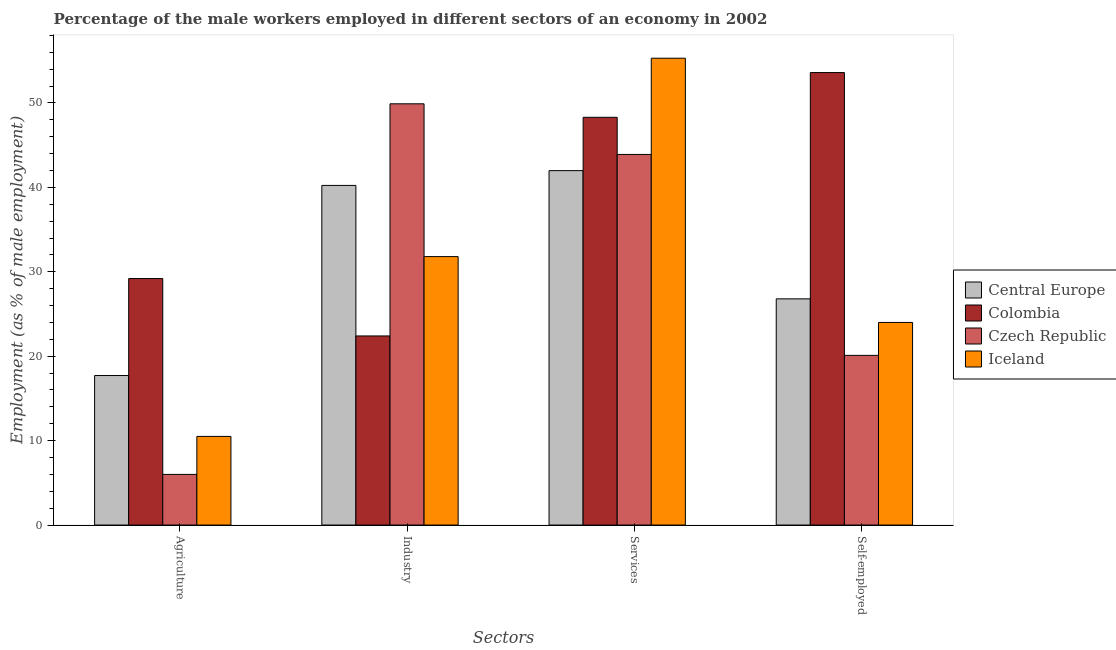How many different coloured bars are there?
Provide a succinct answer. 4. Are the number of bars per tick equal to the number of legend labels?
Provide a short and direct response. Yes. How many bars are there on the 2nd tick from the left?
Offer a terse response. 4. How many bars are there on the 2nd tick from the right?
Keep it short and to the point. 4. What is the label of the 2nd group of bars from the left?
Keep it short and to the point. Industry. What is the percentage of male workers in industry in Central Europe?
Give a very brief answer. 40.23. Across all countries, what is the maximum percentage of self employed male workers?
Offer a terse response. 53.6. Across all countries, what is the minimum percentage of male workers in agriculture?
Give a very brief answer. 6. In which country was the percentage of male workers in agriculture maximum?
Ensure brevity in your answer.  Colombia. In which country was the percentage of male workers in services minimum?
Offer a very short reply. Central Europe. What is the total percentage of male workers in services in the graph?
Provide a short and direct response. 189.48. What is the difference between the percentage of male workers in services in Iceland and that in Central Europe?
Keep it short and to the point. 13.32. What is the difference between the percentage of self employed male workers in Iceland and the percentage of male workers in industry in Central Europe?
Your response must be concise. -16.23. What is the average percentage of male workers in agriculture per country?
Keep it short and to the point. 15.85. What is the difference between the percentage of male workers in agriculture and percentage of male workers in industry in Iceland?
Your answer should be very brief. -21.3. What is the ratio of the percentage of self employed male workers in Iceland to that in Central Europe?
Make the answer very short. 0.9. Is the percentage of male workers in industry in Iceland less than that in Czech Republic?
Your answer should be compact. Yes. What is the difference between the highest and the second highest percentage of self employed male workers?
Offer a very short reply. 26.8. What is the difference between the highest and the lowest percentage of male workers in agriculture?
Offer a very short reply. 23.2. In how many countries, is the percentage of male workers in industry greater than the average percentage of male workers in industry taken over all countries?
Ensure brevity in your answer.  2. Is the sum of the percentage of self employed male workers in Iceland and Czech Republic greater than the maximum percentage of male workers in industry across all countries?
Give a very brief answer. No. Is it the case that in every country, the sum of the percentage of self employed male workers and percentage of male workers in services is greater than the sum of percentage of male workers in industry and percentage of male workers in agriculture?
Give a very brief answer. Yes. What does the 1st bar from the left in Industry represents?
Give a very brief answer. Central Europe. What does the 4th bar from the right in Industry represents?
Offer a terse response. Central Europe. How many countries are there in the graph?
Ensure brevity in your answer.  4. Are the values on the major ticks of Y-axis written in scientific E-notation?
Make the answer very short. No. Does the graph contain any zero values?
Your response must be concise. No. Where does the legend appear in the graph?
Your answer should be compact. Center right. How many legend labels are there?
Provide a short and direct response. 4. How are the legend labels stacked?
Your answer should be compact. Vertical. What is the title of the graph?
Ensure brevity in your answer.  Percentage of the male workers employed in different sectors of an economy in 2002. Does "Brunei Darussalam" appear as one of the legend labels in the graph?
Provide a short and direct response. No. What is the label or title of the X-axis?
Your answer should be very brief. Sectors. What is the label or title of the Y-axis?
Make the answer very short. Employment (as % of male employment). What is the Employment (as % of male employment) in Central Europe in Agriculture?
Offer a very short reply. 17.71. What is the Employment (as % of male employment) of Colombia in Agriculture?
Make the answer very short. 29.2. What is the Employment (as % of male employment) of Central Europe in Industry?
Provide a succinct answer. 40.23. What is the Employment (as % of male employment) in Colombia in Industry?
Provide a succinct answer. 22.4. What is the Employment (as % of male employment) in Czech Republic in Industry?
Make the answer very short. 49.9. What is the Employment (as % of male employment) in Iceland in Industry?
Offer a terse response. 31.8. What is the Employment (as % of male employment) in Central Europe in Services?
Ensure brevity in your answer.  41.98. What is the Employment (as % of male employment) in Colombia in Services?
Offer a terse response. 48.3. What is the Employment (as % of male employment) in Czech Republic in Services?
Give a very brief answer. 43.9. What is the Employment (as % of male employment) of Iceland in Services?
Ensure brevity in your answer.  55.3. What is the Employment (as % of male employment) in Central Europe in Self-employed?
Make the answer very short. 26.8. What is the Employment (as % of male employment) in Colombia in Self-employed?
Keep it short and to the point. 53.6. What is the Employment (as % of male employment) of Czech Republic in Self-employed?
Your answer should be very brief. 20.1. Across all Sectors, what is the maximum Employment (as % of male employment) of Central Europe?
Provide a succinct answer. 41.98. Across all Sectors, what is the maximum Employment (as % of male employment) in Colombia?
Give a very brief answer. 53.6. Across all Sectors, what is the maximum Employment (as % of male employment) of Czech Republic?
Give a very brief answer. 49.9. Across all Sectors, what is the maximum Employment (as % of male employment) in Iceland?
Provide a succinct answer. 55.3. Across all Sectors, what is the minimum Employment (as % of male employment) of Central Europe?
Provide a succinct answer. 17.71. Across all Sectors, what is the minimum Employment (as % of male employment) in Colombia?
Ensure brevity in your answer.  22.4. What is the total Employment (as % of male employment) of Central Europe in the graph?
Your response must be concise. 126.72. What is the total Employment (as % of male employment) in Colombia in the graph?
Your answer should be very brief. 153.5. What is the total Employment (as % of male employment) of Czech Republic in the graph?
Your response must be concise. 119.9. What is the total Employment (as % of male employment) in Iceland in the graph?
Provide a short and direct response. 121.6. What is the difference between the Employment (as % of male employment) of Central Europe in Agriculture and that in Industry?
Make the answer very short. -22.52. What is the difference between the Employment (as % of male employment) of Czech Republic in Agriculture and that in Industry?
Your response must be concise. -43.9. What is the difference between the Employment (as % of male employment) in Iceland in Agriculture and that in Industry?
Provide a succinct answer. -21.3. What is the difference between the Employment (as % of male employment) in Central Europe in Agriculture and that in Services?
Give a very brief answer. -24.27. What is the difference between the Employment (as % of male employment) of Colombia in Agriculture and that in Services?
Your answer should be compact. -19.1. What is the difference between the Employment (as % of male employment) of Czech Republic in Agriculture and that in Services?
Keep it short and to the point. -37.9. What is the difference between the Employment (as % of male employment) in Iceland in Agriculture and that in Services?
Ensure brevity in your answer.  -44.8. What is the difference between the Employment (as % of male employment) in Central Europe in Agriculture and that in Self-employed?
Your response must be concise. -9.08. What is the difference between the Employment (as % of male employment) of Colombia in Agriculture and that in Self-employed?
Your answer should be very brief. -24.4. What is the difference between the Employment (as % of male employment) in Czech Republic in Agriculture and that in Self-employed?
Ensure brevity in your answer.  -14.1. What is the difference between the Employment (as % of male employment) of Central Europe in Industry and that in Services?
Ensure brevity in your answer.  -1.75. What is the difference between the Employment (as % of male employment) in Colombia in Industry and that in Services?
Provide a short and direct response. -25.9. What is the difference between the Employment (as % of male employment) of Czech Republic in Industry and that in Services?
Provide a short and direct response. 6. What is the difference between the Employment (as % of male employment) of Iceland in Industry and that in Services?
Provide a short and direct response. -23.5. What is the difference between the Employment (as % of male employment) in Central Europe in Industry and that in Self-employed?
Offer a terse response. 13.44. What is the difference between the Employment (as % of male employment) in Colombia in Industry and that in Self-employed?
Provide a succinct answer. -31.2. What is the difference between the Employment (as % of male employment) of Czech Republic in Industry and that in Self-employed?
Offer a very short reply. 29.8. What is the difference between the Employment (as % of male employment) of Central Europe in Services and that in Self-employed?
Keep it short and to the point. 15.19. What is the difference between the Employment (as % of male employment) in Colombia in Services and that in Self-employed?
Your answer should be compact. -5.3. What is the difference between the Employment (as % of male employment) of Czech Republic in Services and that in Self-employed?
Provide a succinct answer. 23.8. What is the difference between the Employment (as % of male employment) in Iceland in Services and that in Self-employed?
Provide a succinct answer. 31.3. What is the difference between the Employment (as % of male employment) in Central Europe in Agriculture and the Employment (as % of male employment) in Colombia in Industry?
Offer a very short reply. -4.69. What is the difference between the Employment (as % of male employment) in Central Europe in Agriculture and the Employment (as % of male employment) in Czech Republic in Industry?
Make the answer very short. -32.19. What is the difference between the Employment (as % of male employment) in Central Europe in Agriculture and the Employment (as % of male employment) in Iceland in Industry?
Provide a succinct answer. -14.09. What is the difference between the Employment (as % of male employment) in Colombia in Agriculture and the Employment (as % of male employment) in Czech Republic in Industry?
Give a very brief answer. -20.7. What is the difference between the Employment (as % of male employment) of Czech Republic in Agriculture and the Employment (as % of male employment) of Iceland in Industry?
Provide a short and direct response. -25.8. What is the difference between the Employment (as % of male employment) of Central Europe in Agriculture and the Employment (as % of male employment) of Colombia in Services?
Offer a very short reply. -30.59. What is the difference between the Employment (as % of male employment) in Central Europe in Agriculture and the Employment (as % of male employment) in Czech Republic in Services?
Provide a succinct answer. -26.19. What is the difference between the Employment (as % of male employment) of Central Europe in Agriculture and the Employment (as % of male employment) of Iceland in Services?
Give a very brief answer. -37.59. What is the difference between the Employment (as % of male employment) in Colombia in Agriculture and the Employment (as % of male employment) in Czech Republic in Services?
Make the answer very short. -14.7. What is the difference between the Employment (as % of male employment) of Colombia in Agriculture and the Employment (as % of male employment) of Iceland in Services?
Offer a very short reply. -26.1. What is the difference between the Employment (as % of male employment) of Czech Republic in Agriculture and the Employment (as % of male employment) of Iceland in Services?
Keep it short and to the point. -49.3. What is the difference between the Employment (as % of male employment) in Central Europe in Agriculture and the Employment (as % of male employment) in Colombia in Self-employed?
Give a very brief answer. -35.89. What is the difference between the Employment (as % of male employment) of Central Europe in Agriculture and the Employment (as % of male employment) of Czech Republic in Self-employed?
Your answer should be compact. -2.39. What is the difference between the Employment (as % of male employment) of Central Europe in Agriculture and the Employment (as % of male employment) of Iceland in Self-employed?
Offer a terse response. -6.29. What is the difference between the Employment (as % of male employment) in Colombia in Agriculture and the Employment (as % of male employment) in Czech Republic in Self-employed?
Keep it short and to the point. 9.1. What is the difference between the Employment (as % of male employment) of Colombia in Agriculture and the Employment (as % of male employment) of Iceland in Self-employed?
Your answer should be very brief. 5.2. What is the difference between the Employment (as % of male employment) in Czech Republic in Agriculture and the Employment (as % of male employment) in Iceland in Self-employed?
Offer a very short reply. -18. What is the difference between the Employment (as % of male employment) of Central Europe in Industry and the Employment (as % of male employment) of Colombia in Services?
Provide a short and direct response. -8.07. What is the difference between the Employment (as % of male employment) of Central Europe in Industry and the Employment (as % of male employment) of Czech Republic in Services?
Your response must be concise. -3.67. What is the difference between the Employment (as % of male employment) of Central Europe in Industry and the Employment (as % of male employment) of Iceland in Services?
Offer a terse response. -15.07. What is the difference between the Employment (as % of male employment) of Colombia in Industry and the Employment (as % of male employment) of Czech Republic in Services?
Make the answer very short. -21.5. What is the difference between the Employment (as % of male employment) in Colombia in Industry and the Employment (as % of male employment) in Iceland in Services?
Your response must be concise. -32.9. What is the difference between the Employment (as % of male employment) in Central Europe in Industry and the Employment (as % of male employment) in Colombia in Self-employed?
Offer a very short reply. -13.37. What is the difference between the Employment (as % of male employment) of Central Europe in Industry and the Employment (as % of male employment) of Czech Republic in Self-employed?
Provide a short and direct response. 20.13. What is the difference between the Employment (as % of male employment) in Central Europe in Industry and the Employment (as % of male employment) in Iceland in Self-employed?
Offer a very short reply. 16.23. What is the difference between the Employment (as % of male employment) in Colombia in Industry and the Employment (as % of male employment) in Czech Republic in Self-employed?
Make the answer very short. 2.3. What is the difference between the Employment (as % of male employment) in Czech Republic in Industry and the Employment (as % of male employment) in Iceland in Self-employed?
Give a very brief answer. 25.9. What is the difference between the Employment (as % of male employment) in Central Europe in Services and the Employment (as % of male employment) in Colombia in Self-employed?
Your answer should be very brief. -11.62. What is the difference between the Employment (as % of male employment) of Central Europe in Services and the Employment (as % of male employment) of Czech Republic in Self-employed?
Make the answer very short. 21.88. What is the difference between the Employment (as % of male employment) of Central Europe in Services and the Employment (as % of male employment) of Iceland in Self-employed?
Offer a very short reply. 17.98. What is the difference between the Employment (as % of male employment) in Colombia in Services and the Employment (as % of male employment) in Czech Republic in Self-employed?
Provide a succinct answer. 28.2. What is the difference between the Employment (as % of male employment) in Colombia in Services and the Employment (as % of male employment) in Iceland in Self-employed?
Give a very brief answer. 24.3. What is the average Employment (as % of male employment) in Central Europe per Sectors?
Your response must be concise. 31.68. What is the average Employment (as % of male employment) in Colombia per Sectors?
Offer a terse response. 38.38. What is the average Employment (as % of male employment) in Czech Republic per Sectors?
Provide a short and direct response. 29.98. What is the average Employment (as % of male employment) in Iceland per Sectors?
Keep it short and to the point. 30.4. What is the difference between the Employment (as % of male employment) of Central Europe and Employment (as % of male employment) of Colombia in Agriculture?
Your answer should be compact. -11.49. What is the difference between the Employment (as % of male employment) of Central Europe and Employment (as % of male employment) of Czech Republic in Agriculture?
Your answer should be compact. 11.71. What is the difference between the Employment (as % of male employment) of Central Europe and Employment (as % of male employment) of Iceland in Agriculture?
Provide a succinct answer. 7.21. What is the difference between the Employment (as % of male employment) of Colombia and Employment (as % of male employment) of Czech Republic in Agriculture?
Offer a terse response. 23.2. What is the difference between the Employment (as % of male employment) of Central Europe and Employment (as % of male employment) of Colombia in Industry?
Provide a succinct answer. 17.83. What is the difference between the Employment (as % of male employment) in Central Europe and Employment (as % of male employment) in Czech Republic in Industry?
Provide a succinct answer. -9.67. What is the difference between the Employment (as % of male employment) in Central Europe and Employment (as % of male employment) in Iceland in Industry?
Your answer should be compact. 8.43. What is the difference between the Employment (as % of male employment) in Colombia and Employment (as % of male employment) in Czech Republic in Industry?
Provide a succinct answer. -27.5. What is the difference between the Employment (as % of male employment) in Czech Republic and Employment (as % of male employment) in Iceland in Industry?
Your answer should be very brief. 18.1. What is the difference between the Employment (as % of male employment) in Central Europe and Employment (as % of male employment) in Colombia in Services?
Give a very brief answer. -6.32. What is the difference between the Employment (as % of male employment) of Central Europe and Employment (as % of male employment) of Czech Republic in Services?
Ensure brevity in your answer.  -1.92. What is the difference between the Employment (as % of male employment) of Central Europe and Employment (as % of male employment) of Iceland in Services?
Provide a short and direct response. -13.32. What is the difference between the Employment (as % of male employment) of Colombia and Employment (as % of male employment) of Iceland in Services?
Offer a very short reply. -7. What is the difference between the Employment (as % of male employment) in Czech Republic and Employment (as % of male employment) in Iceland in Services?
Give a very brief answer. -11.4. What is the difference between the Employment (as % of male employment) in Central Europe and Employment (as % of male employment) in Colombia in Self-employed?
Provide a short and direct response. -26.8. What is the difference between the Employment (as % of male employment) of Central Europe and Employment (as % of male employment) of Czech Republic in Self-employed?
Your answer should be compact. 6.7. What is the difference between the Employment (as % of male employment) in Central Europe and Employment (as % of male employment) in Iceland in Self-employed?
Ensure brevity in your answer.  2.8. What is the difference between the Employment (as % of male employment) in Colombia and Employment (as % of male employment) in Czech Republic in Self-employed?
Provide a short and direct response. 33.5. What is the difference between the Employment (as % of male employment) of Colombia and Employment (as % of male employment) of Iceland in Self-employed?
Provide a short and direct response. 29.6. What is the difference between the Employment (as % of male employment) in Czech Republic and Employment (as % of male employment) in Iceland in Self-employed?
Your response must be concise. -3.9. What is the ratio of the Employment (as % of male employment) in Central Europe in Agriculture to that in Industry?
Provide a short and direct response. 0.44. What is the ratio of the Employment (as % of male employment) of Colombia in Agriculture to that in Industry?
Your answer should be very brief. 1.3. What is the ratio of the Employment (as % of male employment) in Czech Republic in Agriculture to that in Industry?
Give a very brief answer. 0.12. What is the ratio of the Employment (as % of male employment) in Iceland in Agriculture to that in Industry?
Keep it short and to the point. 0.33. What is the ratio of the Employment (as % of male employment) in Central Europe in Agriculture to that in Services?
Your answer should be compact. 0.42. What is the ratio of the Employment (as % of male employment) in Colombia in Agriculture to that in Services?
Offer a very short reply. 0.6. What is the ratio of the Employment (as % of male employment) in Czech Republic in Agriculture to that in Services?
Provide a short and direct response. 0.14. What is the ratio of the Employment (as % of male employment) of Iceland in Agriculture to that in Services?
Ensure brevity in your answer.  0.19. What is the ratio of the Employment (as % of male employment) of Central Europe in Agriculture to that in Self-employed?
Keep it short and to the point. 0.66. What is the ratio of the Employment (as % of male employment) of Colombia in Agriculture to that in Self-employed?
Provide a short and direct response. 0.54. What is the ratio of the Employment (as % of male employment) in Czech Republic in Agriculture to that in Self-employed?
Give a very brief answer. 0.3. What is the ratio of the Employment (as % of male employment) in Iceland in Agriculture to that in Self-employed?
Offer a terse response. 0.44. What is the ratio of the Employment (as % of male employment) of Colombia in Industry to that in Services?
Offer a very short reply. 0.46. What is the ratio of the Employment (as % of male employment) in Czech Republic in Industry to that in Services?
Your answer should be very brief. 1.14. What is the ratio of the Employment (as % of male employment) in Iceland in Industry to that in Services?
Provide a succinct answer. 0.57. What is the ratio of the Employment (as % of male employment) in Central Europe in Industry to that in Self-employed?
Provide a short and direct response. 1.5. What is the ratio of the Employment (as % of male employment) in Colombia in Industry to that in Self-employed?
Your answer should be very brief. 0.42. What is the ratio of the Employment (as % of male employment) in Czech Republic in Industry to that in Self-employed?
Your answer should be compact. 2.48. What is the ratio of the Employment (as % of male employment) of Iceland in Industry to that in Self-employed?
Keep it short and to the point. 1.32. What is the ratio of the Employment (as % of male employment) in Central Europe in Services to that in Self-employed?
Keep it short and to the point. 1.57. What is the ratio of the Employment (as % of male employment) in Colombia in Services to that in Self-employed?
Your response must be concise. 0.9. What is the ratio of the Employment (as % of male employment) of Czech Republic in Services to that in Self-employed?
Provide a succinct answer. 2.18. What is the ratio of the Employment (as % of male employment) in Iceland in Services to that in Self-employed?
Keep it short and to the point. 2.3. What is the difference between the highest and the second highest Employment (as % of male employment) of Central Europe?
Give a very brief answer. 1.75. What is the difference between the highest and the second highest Employment (as % of male employment) of Czech Republic?
Offer a very short reply. 6. What is the difference between the highest and the lowest Employment (as % of male employment) in Central Europe?
Keep it short and to the point. 24.27. What is the difference between the highest and the lowest Employment (as % of male employment) of Colombia?
Ensure brevity in your answer.  31.2. What is the difference between the highest and the lowest Employment (as % of male employment) of Czech Republic?
Offer a terse response. 43.9. What is the difference between the highest and the lowest Employment (as % of male employment) of Iceland?
Give a very brief answer. 44.8. 